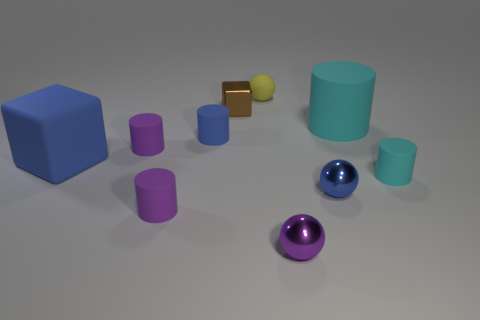The cyan matte thing that is the same size as the blue rubber block is what shape? cylinder 